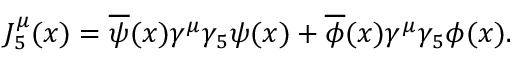Convert formula to latex. <formula><loc_0><loc_0><loc_500><loc_500>J _ { 5 } ^ { \mu } ( x ) = \overline { \psi } ( x ) \gamma ^ { \mu } \gamma _ { 5 } \psi ( x ) + \overline { \phi } ( x ) \gamma ^ { \mu } \gamma _ { 5 } \phi ( x ) .</formula> 